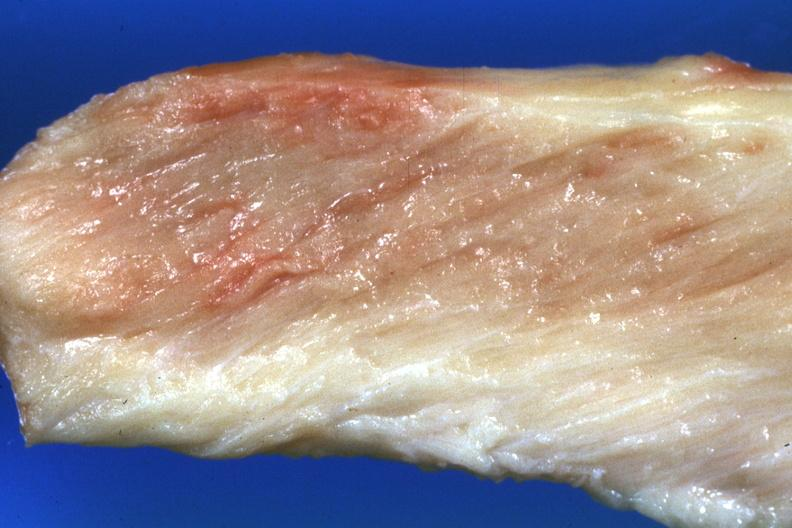what do close-up view pale?
Answer the question using a single word or phrase. View pale muscle 